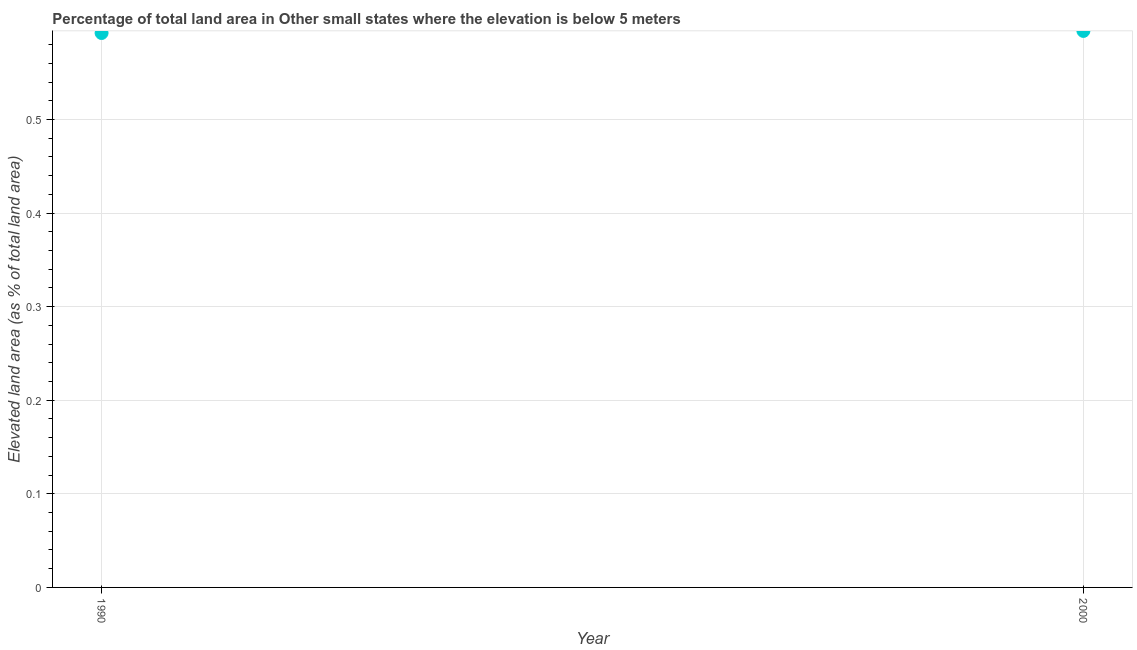What is the total elevated land area in 2000?
Your response must be concise. 0.59. Across all years, what is the maximum total elevated land area?
Offer a terse response. 0.59. Across all years, what is the minimum total elevated land area?
Give a very brief answer. 0.59. In which year was the total elevated land area maximum?
Offer a terse response. 2000. In which year was the total elevated land area minimum?
Offer a terse response. 1990. What is the sum of the total elevated land area?
Give a very brief answer. 1.19. What is the difference between the total elevated land area in 1990 and 2000?
Your answer should be very brief. -0. What is the average total elevated land area per year?
Your answer should be compact. 0.59. What is the median total elevated land area?
Give a very brief answer. 0.59. In how many years, is the total elevated land area greater than 0.42000000000000004 %?
Offer a terse response. 2. What is the ratio of the total elevated land area in 1990 to that in 2000?
Offer a terse response. 1. Is the total elevated land area in 1990 less than that in 2000?
Keep it short and to the point. Yes. In how many years, is the total elevated land area greater than the average total elevated land area taken over all years?
Provide a short and direct response. 1. How many dotlines are there?
Give a very brief answer. 1. What is the title of the graph?
Provide a succinct answer. Percentage of total land area in Other small states where the elevation is below 5 meters. What is the label or title of the Y-axis?
Make the answer very short. Elevated land area (as % of total land area). What is the Elevated land area (as % of total land area) in 1990?
Your answer should be compact. 0.59. What is the Elevated land area (as % of total land area) in 2000?
Provide a short and direct response. 0.59. What is the difference between the Elevated land area (as % of total land area) in 1990 and 2000?
Offer a terse response. -0. 